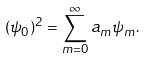Convert formula to latex. <formula><loc_0><loc_0><loc_500><loc_500>( \psi _ { 0 } ) ^ { 2 } = \sum _ { m = 0 } ^ { \infty } a _ { m } \psi _ { m } .</formula> 